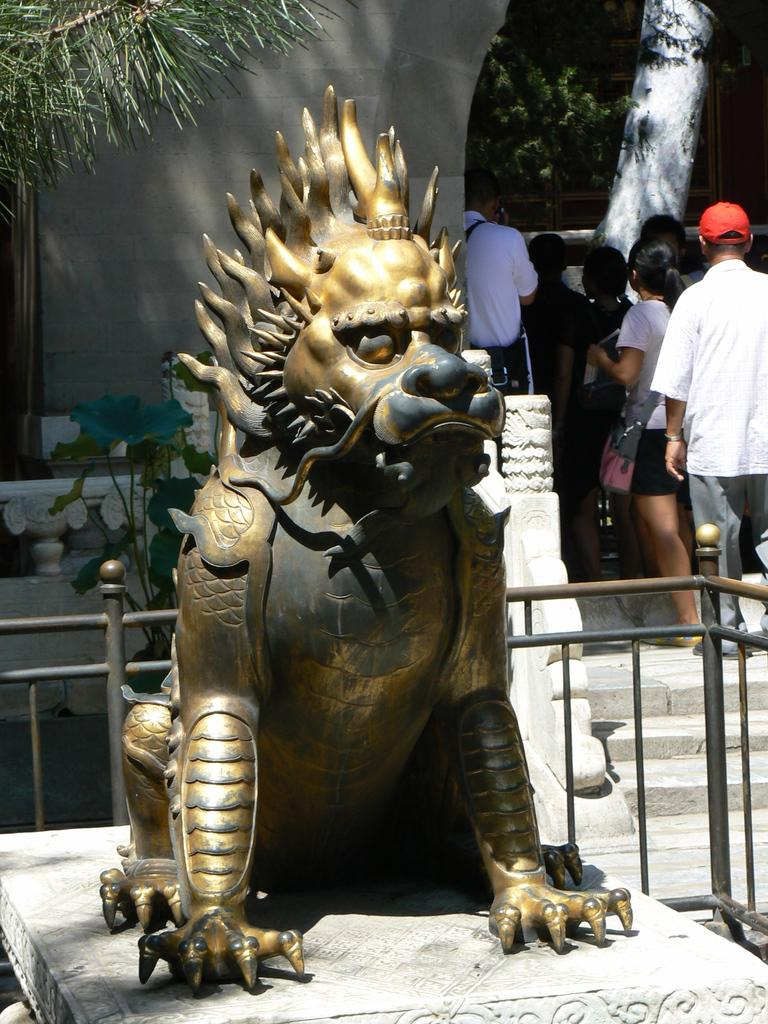What is the main subject in the image? There is a sculpture in the image. What other objects or features can be seen in the image? There is an iron railing, people near a wall, a plant, and trees in the background of the image. Can you see any smoke coming from the sculpture in the image? There is no smoke present in the image. The sculpture is a stationary object, and there is no indication of any smoke or fire in the image. 